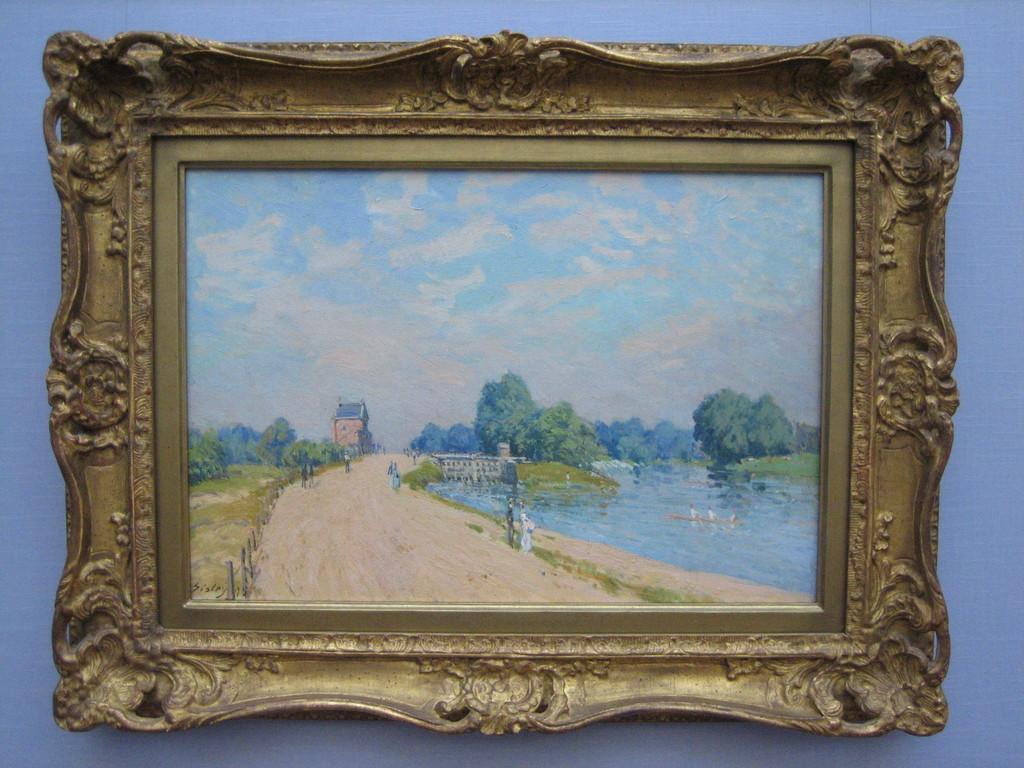Describe this image in one or two sentences. In this picture there is a painting frame which is placed on the wall. In the painting I can see the sky, clouds, trees, building, fencing, farmland, ducks, water, grass and plants. 